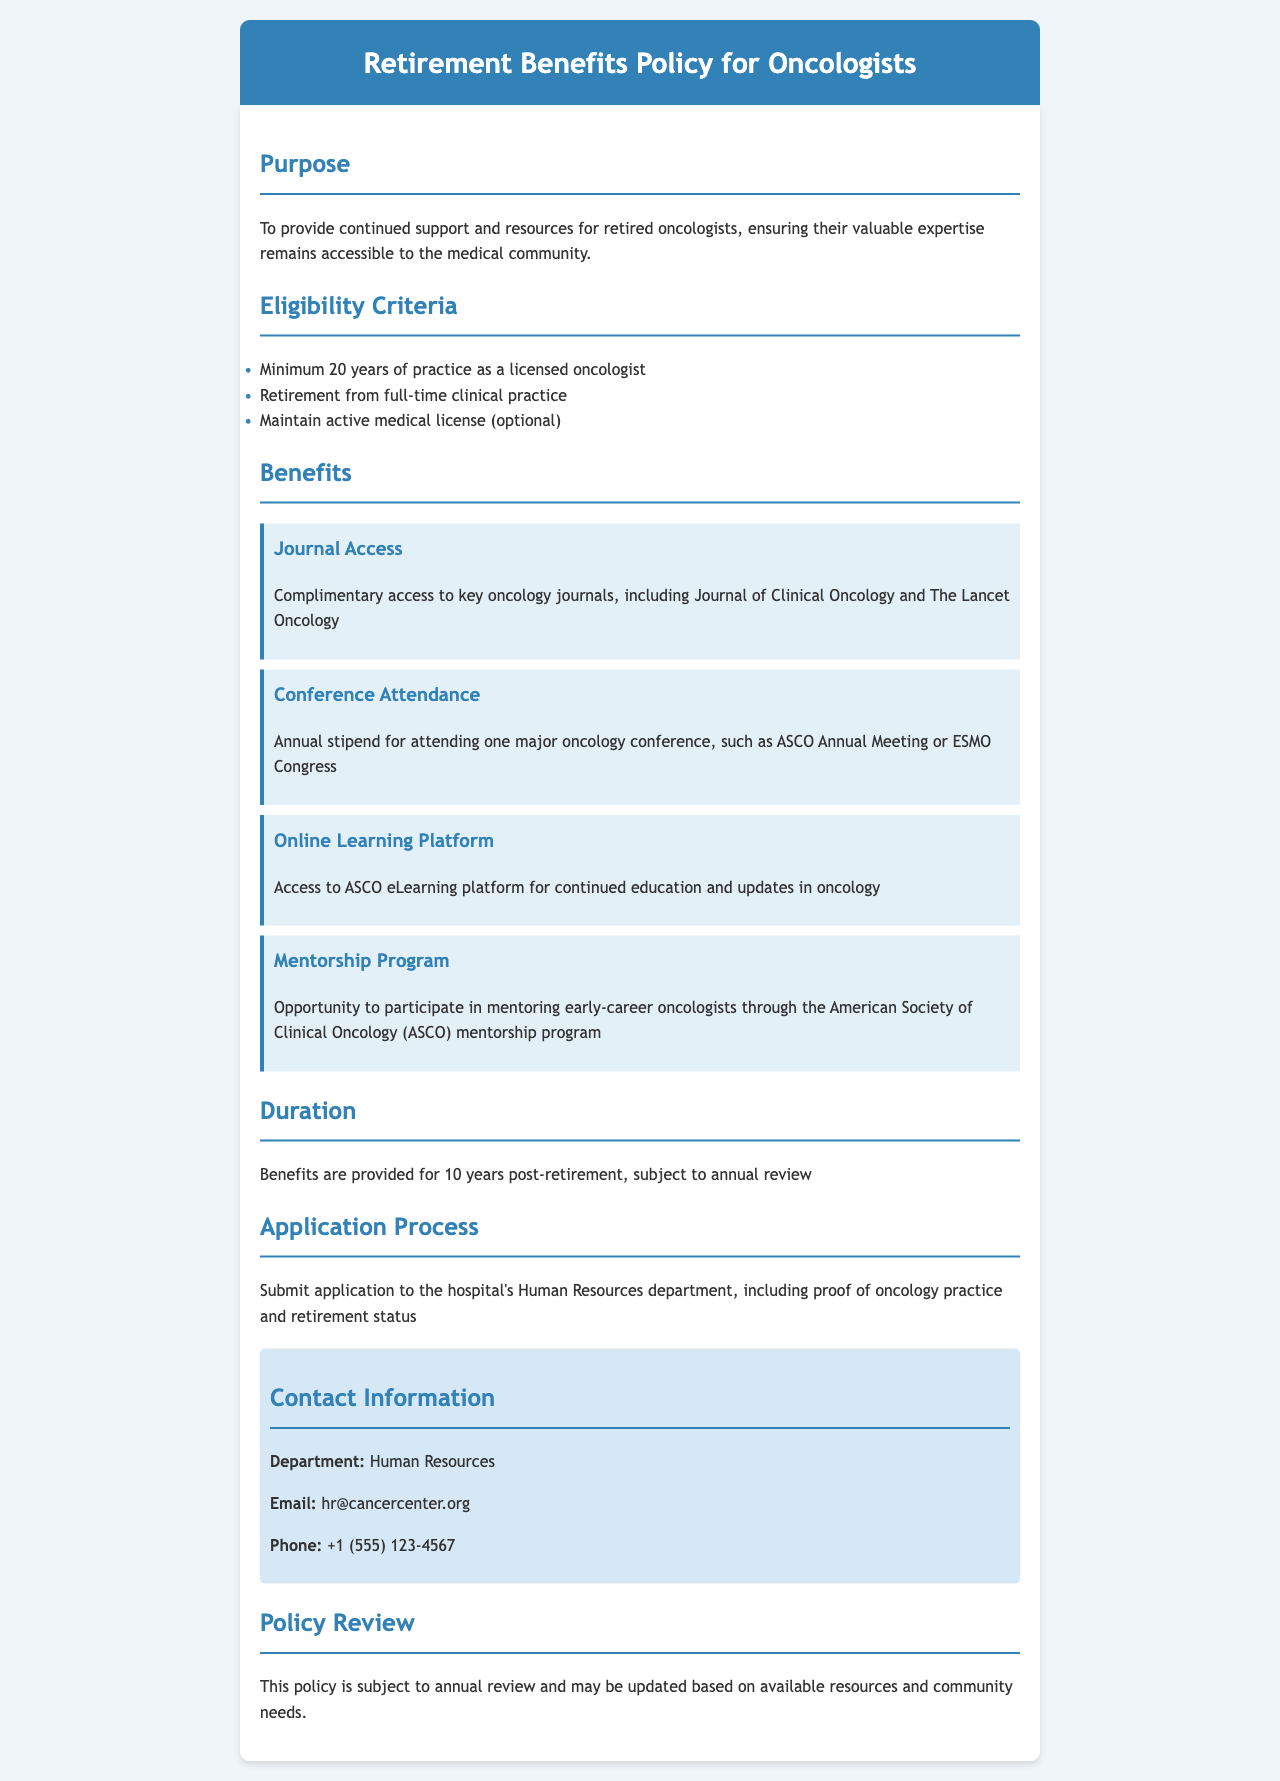What is the purpose of the policy? The purpose is to provide continued support and resources for retired oncologists, ensuring their valuable expertise remains accessible to the medical community.
Answer: Continued support and resources for retired oncologists What is the minimum practice duration required for eligibility? Eligibility requires a minimum of 20 years of practice as a licensed oncologist, as stated in the eligibility criteria.
Answer: 20 years Which journals do retired oncologists receive complimentary access to? The policy specifies complimentary access to key oncology journals, including Journal of Clinical Oncology and The Lancet Oncology.
Answer: Journal of Clinical Oncology and The Lancet Oncology How long are the benefits provided post-retirement? The document states that benefits are provided for 10 years post-retirement, subject to annual review, clarifying the duration of benefits.
Answer: 10 years What is the email contact for Human Resources? The contact information section includes the email address for Human Resources, which is directly stated in the document.
Answer: hr@cancercenter.org What is one major conference mentioned for attendance? The document lists the ASCO Annual Meeting as one major oncology conference for which an annual stipend for attendance is provided.
Answer: ASCO Annual Meeting What program allows participation in mentoring? The policy outlines the opportunity to participate in mentoring early-career oncologists through the mentorship program of the American Society of Clinical Oncology (ASCO).
Answer: ASCO mentorship program What department handles the application process? The application process requires submitting an application to the hospital's Human Resources department, as indicated in the document.
Answer: Human Resources 